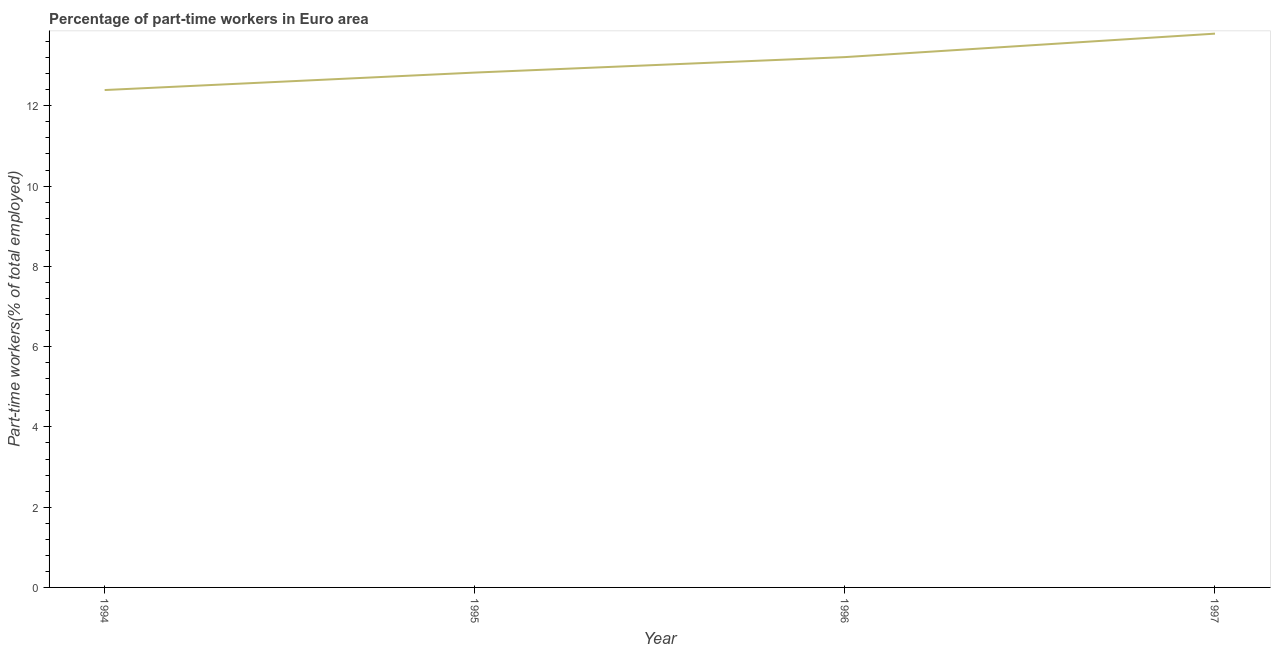What is the percentage of part-time workers in 1996?
Ensure brevity in your answer.  13.21. Across all years, what is the maximum percentage of part-time workers?
Give a very brief answer. 13.8. Across all years, what is the minimum percentage of part-time workers?
Your answer should be compact. 12.39. In which year was the percentage of part-time workers maximum?
Provide a short and direct response. 1997. In which year was the percentage of part-time workers minimum?
Your answer should be compact. 1994. What is the sum of the percentage of part-time workers?
Offer a very short reply. 52.24. What is the difference between the percentage of part-time workers in 1995 and 1997?
Provide a succinct answer. -0.97. What is the average percentage of part-time workers per year?
Keep it short and to the point. 13.06. What is the median percentage of part-time workers?
Your answer should be compact. 13.02. In how many years, is the percentage of part-time workers greater than 0.4 %?
Your answer should be very brief. 4. What is the ratio of the percentage of part-time workers in 1995 to that in 1996?
Offer a very short reply. 0.97. Is the percentage of part-time workers in 1994 less than that in 1996?
Your answer should be very brief. Yes. What is the difference between the highest and the second highest percentage of part-time workers?
Provide a short and direct response. 0.58. What is the difference between the highest and the lowest percentage of part-time workers?
Offer a terse response. 1.41. Does the percentage of part-time workers monotonically increase over the years?
Offer a very short reply. Yes. How many lines are there?
Ensure brevity in your answer.  1. Does the graph contain any zero values?
Your response must be concise. No. What is the title of the graph?
Offer a terse response. Percentage of part-time workers in Euro area. What is the label or title of the Y-axis?
Your answer should be compact. Part-time workers(% of total employed). What is the Part-time workers(% of total employed) in 1994?
Offer a terse response. 12.39. What is the Part-time workers(% of total employed) in 1995?
Keep it short and to the point. 12.83. What is the Part-time workers(% of total employed) of 1996?
Your answer should be compact. 13.21. What is the Part-time workers(% of total employed) in 1997?
Your response must be concise. 13.8. What is the difference between the Part-time workers(% of total employed) in 1994 and 1995?
Ensure brevity in your answer.  -0.44. What is the difference between the Part-time workers(% of total employed) in 1994 and 1996?
Your answer should be compact. -0.82. What is the difference between the Part-time workers(% of total employed) in 1994 and 1997?
Provide a succinct answer. -1.41. What is the difference between the Part-time workers(% of total employed) in 1995 and 1996?
Your response must be concise. -0.39. What is the difference between the Part-time workers(% of total employed) in 1995 and 1997?
Your answer should be compact. -0.97. What is the difference between the Part-time workers(% of total employed) in 1996 and 1997?
Your answer should be very brief. -0.58. What is the ratio of the Part-time workers(% of total employed) in 1994 to that in 1996?
Provide a short and direct response. 0.94. What is the ratio of the Part-time workers(% of total employed) in 1994 to that in 1997?
Keep it short and to the point. 0.9. What is the ratio of the Part-time workers(% of total employed) in 1995 to that in 1996?
Your response must be concise. 0.97. What is the ratio of the Part-time workers(% of total employed) in 1996 to that in 1997?
Your answer should be very brief. 0.96. 